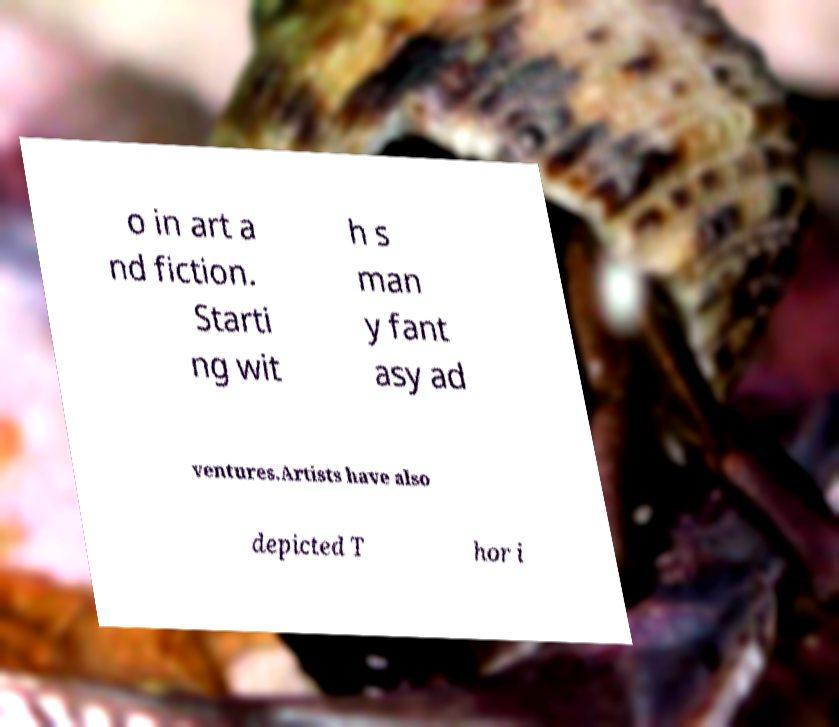Please read and relay the text visible in this image. What does it say? o in art a nd fiction. Starti ng wit h s man y fant asy ad ventures.Artists have also depicted T hor i 